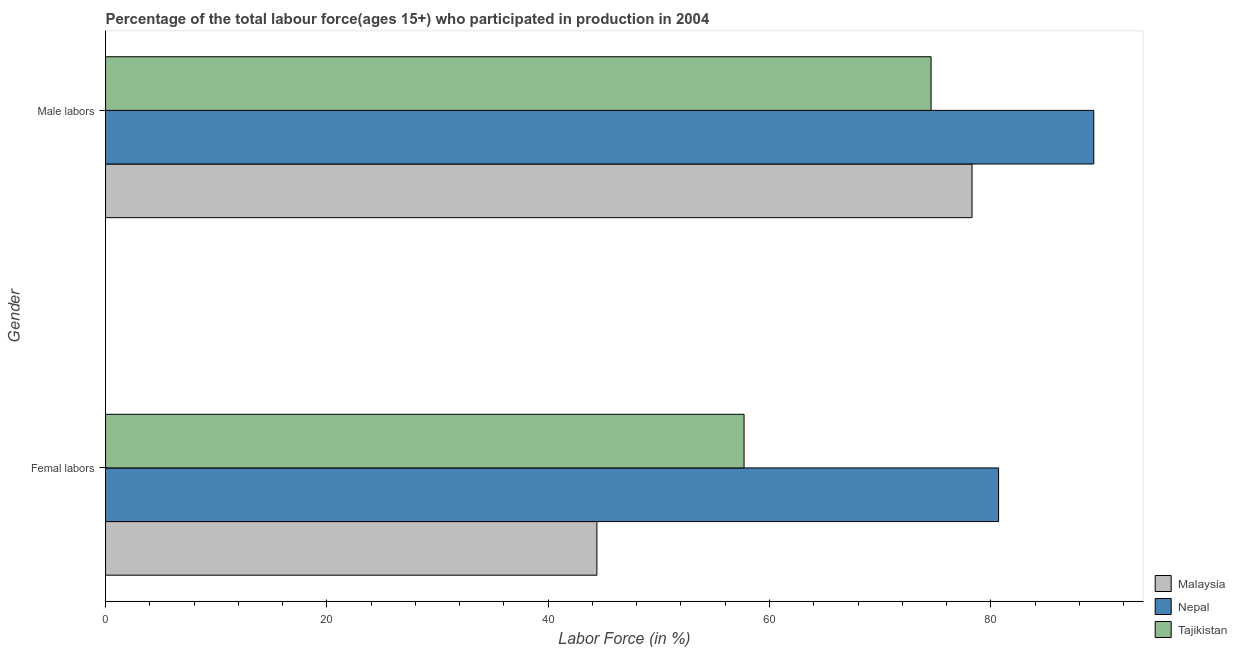How many groups of bars are there?
Provide a succinct answer. 2. Are the number of bars per tick equal to the number of legend labels?
Provide a succinct answer. Yes. How many bars are there on the 1st tick from the top?
Make the answer very short. 3. How many bars are there on the 1st tick from the bottom?
Your answer should be compact. 3. What is the label of the 2nd group of bars from the top?
Keep it short and to the point. Femal labors. What is the percentage of male labour force in Tajikistan?
Offer a terse response. 74.6. Across all countries, what is the maximum percentage of male labour force?
Keep it short and to the point. 89.3. Across all countries, what is the minimum percentage of female labor force?
Give a very brief answer. 44.4. In which country was the percentage of male labour force maximum?
Provide a succinct answer. Nepal. In which country was the percentage of female labor force minimum?
Offer a terse response. Malaysia. What is the total percentage of female labor force in the graph?
Provide a short and direct response. 182.8. What is the difference between the percentage of male labour force in Malaysia and that in Nepal?
Ensure brevity in your answer.  -11. What is the difference between the percentage of male labour force in Nepal and the percentage of female labor force in Tajikistan?
Make the answer very short. 31.6. What is the average percentage of female labor force per country?
Your response must be concise. 60.93. What is the difference between the percentage of female labor force and percentage of male labour force in Tajikistan?
Give a very brief answer. -16.9. What is the ratio of the percentage of male labour force in Malaysia to that in Nepal?
Give a very brief answer. 0.88. Is the percentage of male labour force in Malaysia less than that in Tajikistan?
Offer a terse response. No. In how many countries, is the percentage of female labor force greater than the average percentage of female labor force taken over all countries?
Offer a terse response. 1. What does the 3rd bar from the top in Femal labors represents?
Your response must be concise. Malaysia. What does the 1st bar from the bottom in Femal labors represents?
Your answer should be compact. Malaysia. How many bars are there?
Give a very brief answer. 6. Are all the bars in the graph horizontal?
Offer a terse response. Yes. How many countries are there in the graph?
Ensure brevity in your answer.  3. Are the values on the major ticks of X-axis written in scientific E-notation?
Your answer should be very brief. No. Where does the legend appear in the graph?
Ensure brevity in your answer.  Bottom right. What is the title of the graph?
Give a very brief answer. Percentage of the total labour force(ages 15+) who participated in production in 2004. Does "Netherlands" appear as one of the legend labels in the graph?
Offer a terse response. No. What is the Labor Force (in %) in Malaysia in Femal labors?
Keep it short and to the point. 44.4. What is the Labor Force (in %) in Nepal in Femal labors?
Ensure brevity in your answer.  80.7. What is the Labor Force (in %) of Tajikistan in Femal labors?
Provide a short and direct response. 57.7. What is the Labor Force (in %) in Malaysia in Male labors?
Provide a succinct answer. 78.3. What is the Labor Force (in %) of Nepal in Male labors?
Give a very brief answer. 89.3. What is the Labor Force (in %) in Tajikistan in Male labors?
Provide a succinct answer. 74.6. Across all Gender, what is the maximum Labor Force (in %) in Malaysia?
Your response must be concise. 78.3. Across all Gender, what is the maximum Labor Force (in %) in Nepal?
Make the answer very short. 89.3. Across all Gender, what is the maximum Labor Force (in %) of Tajikistan?
Ensure brevity in your answer.  74.6. Across all Gender, what is the minimum Labor Force (in %) of Malaysia?
Ensure brevity in your answer.  44.4. Across all Gender, what is the minimum Labor Force (in %) of Nepal?
Give a very brief answer. 80.7. Across all Gender, what is the minimum Labor Force (in %) in Tajikistan?
Keep it short and to the point. 57.7. What is the total Labor Force (in %) of Malaysia in the graph?
Ensure brevity in your answer.  122.7. What is the total Labor Force (in %) in Nepal in the graph?
Provide a short and direct response. 170. What is the total Labor Force (in %) in Tajikistan in the graph?
Provide a short and direct response. 132.3. What is the difference between the Labor Force (in %) in Malaysia in Femal labors and that in Male labors?
Your answer should be very brief. -33.9. What is the difference between the Labor Force (in %) in Nepal in Femal labors and that in Male labors?
Make the answer very short. -8.6. What is the difference between the Labor Force (in %) of Tajikistan in Femal labors and that in Male labors?
Provide a short and direct response. -16.9. What is the difference between the Labor Force (in %) in Malaysia in Femal labors and the Labor Force (in %) in Nepal in Male labors?
Keep it short and to the point. -44.9. What is the difference between the Labor Force (in %) of Malaysia in Femal labors and the Labor Force (in %) of Tajikistan in Male labors?
Make the answer very short. -30.2. What is the difference between the Labor Force (in %) of Nepal in Femal labors and the Labor Force (in %) of Tajikistan in Male labors?
Ensure brevity in your answer.  6.1. What is the average Labor Force (in %) of Malaysia per Gender?
Give a very brief answer. 61.35. What is the average Labor Force (in %) of Nepal per Gender?
Make the answer very short. 85. What is the average Labor Force (in %) in Tajikistan per Gender?
Provide a short and direct response. 66.15. What is the difference between the Labor Force (in %) of Malaysia and Labor Force (in %) of Nepal in Femal labors?
Offer a very short reply. -36.3. What is the difference between the Labor Force (in %) of Malaysia and Labor Force (in %) of Tajikistan in Femal labors?
Make the answer very short. -13.3. What is the difference between the Labor Force (in %) of Nepal and Labor Force (in %) of Tajikistan in Femal labors?
Keep it short and to the point. 23. What is the difference between the Labor Force (in %) of Malaysia and Labor Force (in %) of Tajikistan in Male labors?
Provide a short and direct response. 3.7. What is the difference between the Labor Force (in %) in Nepal and Labor Force (in %) in Tajikistan in Male labors?
Make the answer very short. 14.7. What is the ratio of the Labor Force (in %) of Malaysia in Femal labors to that in Male labors?
Make the answer very short. 0.57. What is the ratio of the Labor Force (in %) in Nepal in Femal labors to that in Male labors?
Offer a terse response. 0.9. What is the ratio of the Labor Force (in %) of Tajikistan in Femal labors to that in Male labors?
Your answer should be very brief. 0.77. What is the difference between the highest and the second highest Labor Force (in %) in Malaysia?
Provide a short and direct response. 33.9. What is the difference between the highest and the second highest Labor Force (in %) of Tajikistan?
Give a very brief answer. 16.9. What is the difference between the highest and the lowest Labor Force (in %) of Malaysia?
Make the answer very short. 33.9. What is the difference between the highest and the lowest Labor Force (in %) of Tajikistan?
Ensure brevity in your answer.  16.9. 